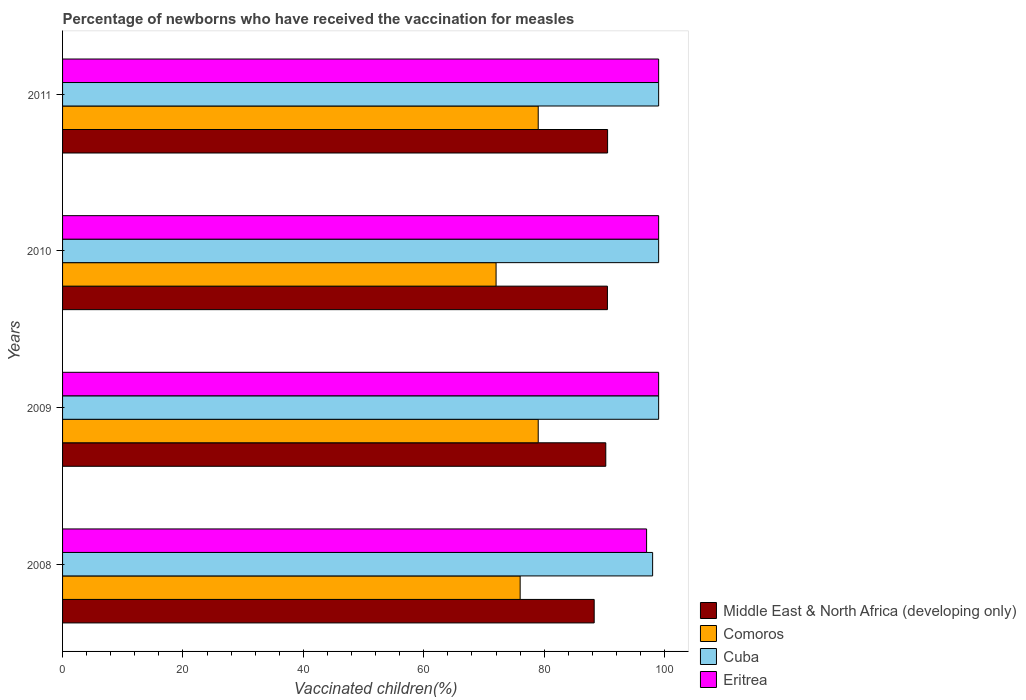How many different coloured bars are there?
Your answer should be very brief. 4. Are the number of bars per tick equal to the number of legend labels?
Provide a succinct answer. Yes. Are the number of bars on each tick of the Y-axis equal?
Make the answer very short. Yes. How many bars are there on the 2nd tick from the top?
Give a very brief answer. 4. In how many cases, is the number of bars for a given year not equal to the number of legend labels?
Provide a succinct answer. 0. What is the percentage of vaccinated children in Middle East & North Africa (developing only) in 2011?
Your answer should be very brief. 90.52. Across all years, what is the maximum percentage of vaccinated children in Middle East & North Africa (developing only)?
Make the answer very short. 90.52. Across all years, what is the minimum percentage of vaccinated children in Middle East & North Africa (developing only)?
Your answer should be very brief. 88.29. In which year was the percentage of vaccinated children in Middle East & North Africa (developing only) maximum?
Your answer should be very brief. 2011. What is the total percentage of vaccinated children in Middle East & North Africa (developing only) in the graph?
Keep it short and to the point. 359.53. What is the difference between the percentage of vaccinated children in Middle East & North Africa (developing only) in 2010 and that in 2011?
Keep it short and to the point. -0.03. What is the difference between the percentage of vaccinated children in Eritrea in 2010 and the percentage of vaccinated children in Middle East & North Africa (developing only) in 2009?
Offer a terse response. 8.78. What is the average percentage of vaccinated children in Cuba per year?
Your response must be concise. 98.75. In the year 2011, what is the difference between the percentage of vaccinated children in Eritrea and percentage of vaccinated children in Cuba?
Offer a very short reply. 0. Is the difference between the percentage of vaccinated children in Eritrea in 2009 and 2010 greater than the difference between the percentage of vaccinated children in Cuba in 2009 and 2010?
Provide a short and direct response. No. What is the difference between the highest and the lowest percentage of vaccinated children in Comoros?
Provide a succinct answer. 7. In how many years, is the percentage of vaccinated children in Comoros greater than the average percentage of vaccinated children in Comoros taken over all years?
Your response must be concise. 2. Is the sum of the percentage of vaccinated children in Comoros in 2008 and 2010 greater than the maximum percentage of vaccinated children in Middle East & North Africa (developing only) across all years?
Your answer should be very brief. Yes. Is it the case that in every year, the sum of the percentage of vaccinated children in Comoros and percentage of vaccinated children in Eritrea is greater than the sum of percentage of vaccinated children in Cuba and percentage of vaccinated children in Middle East & North Africa (developing only)?
Provide a succinct answer. No. What does the 3rd bar from the top in 2009 represents?
Your answer should be compact. Comoros. What does the 3rd bar from the bottom in 2011 represents?
Offer a terse response. Cuba. Is it the case that in every year, the sum of the percentage of vaccinated children in Comoros and percentage of vaccinated children in Cuba is greater than the percentage of vaccinated children in Eritrea?
Make the answer very short. Yes. How many bars are there?
Keep it short and to the point. 16. Are all the bars in the graph horizontal?
Your answer should be compact. Yes. Does the graph contain grids?
Ensure brevity in your answer.  No. How are the legend labels stacked?
Offer a terse response. Vertical. What is the title of the graph?
Give a very brief answer. Percentage of newborns who have received the vaccination for measles. Does "Guam" appear as one of the legend labels in the graph?
Your answer should be compact. No. What is the label or title of the X-axis?
Provide a short and direct response. Vaccinated children(%). What is the Vaccinated children(%) in Middle East & North Africa (developing only) in 2008?
Provide a short and direct response. 88.29. What is the Vaccinated children(%) of Comoros in 2008?
Give a very brief answer. 76. What is the Vaccinated children(%) of Cuba in 2008?
Give a very brief answer. 98. What is the Vaccinated children(%) of Eritrea in 2008?
Your answer should be very brief. 97. What is the Vaccinated children(%) of Middle East & North Africa (developing only) in 2009?
Your answer should be very brief. 90.22. What is the Vaccinated children(%) in Comoros in 2009?
Offer a terse response. 79. What is the Vaccinated children(%) in Cuba in 2009?
Provide a succinct answer. 99. What is the Vaccinated children(%) of Eritrea in 2009?
Your answer should be compact. 99. What is the Vaccinated children(%) in Middle East & North Africa (developing only) in 2010?
Offer a very short reply. 90.49. What is the Vaccinated children(%) in Comoros in 2010?
Your response must be concise. 72. What is the Vaccinated children(%) of Eritrea in 2010?
Make the answer very short. 99. What is the Vaccinated children(%) of Middle East & North Africa (developing only) in 2011?
Offer a terse response. 90.52. What is the Vaccinated children(%) in Comoros in 2011?
Your answer should be very brief. 79. What is the Vaccinated children(%) of Cuba in 2011?
Offer a very short reply. 99. Across all years, what is the maximum Vaccinated children(%) in Middle East & North Africa (developing only)?
Offer a very short reply. 90.52. Across all years, what is the maximum Vaccinated children(%) in Comoros?
Offer a terse response. 79. Across all years, what is the maximum Vaccinated children(%) in Cuba?
Keep it short and to the point. 99. Across all years, what is the minimum Vaccinated children(%) in Middle East & North Africa (developing only)?
Provide a succinct answer. 88.29. Across all years, what is the minimum Vaccinated children(%) in Eritrea?
Your answer should be very brief. 97. What is the total Vaccinated children(%) of Middle East & North Africa (developing only) in the graph?
Make the answer very short. 359.53. What is the total Vaccinated children(%) of Comoros in the graph?
Provide a short and direct response. 306. What is the total Vaccinated children(%) in Cuba in the graph?
Make the answer very short. 395. What is the total Vaccinated children(%) of Eritrea in the graph?
Provide a short and direct response. 394. What is the difference between the Vaccinated children(%) in Middle East & North Africa (developing only) in 2008 and that in 2009?
Your answer should be compact. -1.93. What is the difference between the Vaccinated children(%) of Comoros in 2008 and that in 2009?
Your answer should be very brief. -3. What is the difference between the Vaccinated children(%) in Cuba in 2008 and that in 2009?
Your answer should be very brief. -1. What is the difference between the Vaccinated children(%) of Eritrea in 2008 and that in 2009?
Offer a terse response. -2. What is the difference between the Vaccinated children(%) of Middle East & North Africa (developing only) in 2008 and that in 2010?
Provide a short and direct response. -2.2. What is the difference between the Vaccinated children(%) of Comoros in 2008 and that in 2010?
Provide a short and direct response. 4. What is the difference between the Vaccinated children(%) of Middle East & North Africa (developing only) in 2008 and that in 2011?
Offer a very short reply. -2.23. What is the difference between the Vaccinated children(%) of Middle East & North Africa (developing only) in 2009 and that in 2010?
Your answer should be very brief. -0.27. What is the difference between the Vaccinated children(%) of Eritrea in 2009 and that in 2010?
Your response must be concise. 0. What is the difference between the Vaccinated children(%) of Middle East & North Africa (developing only) in 2009 and that in 2011?
Make the answer very short. -0.3. What is the difference between the Vaccinated children(%) of Comoros in 2009 and that in 2011?
Provide a succinct answer. 0. What is the difference between the Vaccinated children(%) in Cuba in 2009 and that in 2011?
Keep it short and to the point. 0. What is the difference between the Vaccinated children(%) in Middle East & North Africa (developing only) in 2010 and that in 2011?
Offer a terse response. -0.03. What is the difference between the Vaccinated children(%) in Comoros in 2010 and that in 2011?
Ensure brevity in your answer.  -7. What is the difference between the Vaccinated children(%) in Cuba in 2010 and that in 2011?
Your response must be concise. 0. What is the difference between the Vaccinated children(%) in Middle East & North Africa (developing only) in 2008 and the Vaccinated children(%) in Comoros in 2009?
Ensure brevity in your answer.  9.29. What is the difference between the Vaccinated children(%) in Middle East & North Africa (developing only) in 2008 and the Vaccinated children(%) in Cuba in 2009?
Your answer should be very brief. -10.71. What is the difference between the Vaccinated children(%) of Middle East & North Africa (developing only) in 2008 and the Vaccinated children(%) of Eritrea in 2009?
Offer a terse response. -10.71. What is the difference between the Vaccinated children(%) in Cuba in 2008 and the Vaccinated children(%) in Eritrea in 2009?
Your response must be concise. -1. What is the difference between the Vaccinated children(%) of Middle East & North Africa (developing only) in 2008 and the Vaccinated children(%) of Comoros in 2010?
Your answer should be very brief. 16.29. What is the difference between the Vaccinated children(%) of Middle East & North Africa (developing only) in 2008 and the Vaccinated children(%) of Cuba in 2010?
Offer a terse response. -10.71. What is the difference between the Vaccinated children(%) in Middle East & North Africa (developing only) in 2008 and the Vaccinated children(%) in Eritrea in 2010?
Offer a terse response. -10.71. What is the difference between the Vaccinated children(%) in Comoros in 2008 and the Vaccinated children(%) in Cuba in 2010?
Give a very brief answer. -23. What is the difference between the Vaccinated children(%) of Middle East & North Africa (developing only) in 2008 and the Vaccinated children(%) of Comoros in 2011?
Ensure brevity in your answer.  9.29. What is the difference between the Vaccinated children(%) in Middle East & North Africa (developing only) in 2008 and the Vaccinated children(%) in Cuba in 2011?
Your answer should be very brief. -10.71. What is the difference between the Vaccinated children(%) in Middle East & North Africa (developing only) in 2008 and the Vaccinated children(%) in Eritrea in 2011?
Your response must be concise. -10.71. What is the difference between the Vaccinated children(%) in Cuba in 2008 and the Vaccinated children(%) in Eritrea in 2011?
Your answer should be very brief. -1. What is the difference between the Vaccinated children(%) in Middle East & North Africa (developing only) in 2009 and the Vaccinated children(%) in Comoros in 2010?
Your answer should be very brief. 18.22. What is the difference between the Vaccinated children(%) of Middle East & North Africa (developing only) in 2009 and the Vaccinated children(%) of Cuba in 2010?
Provide a succinct answer. -8.78. What is the difference between the Vaccinated children(%) of Middle East & North Africa (developing only) in 2009 and the Vaccinated children(%) of Eritrea in 2010?
Offer a very short reply. -8.78. What is the difference between the Vaccinated children(%) of Comoros in 2009 and the Vaccinated children(%) of Cuba in 2010?
Your answer should be compact. -20. What is the difference between the Vaccinated children(%) of Middle East & North Africa (developing only) in 2009 and the Vaccinated children(%) of Comoros in 2011?
Your response must be concise. 11.22. What is the difference between the Vaccinated children(%) in Middle East & North Africa (developing only) in 2009 and the Vaccinated children(%) in Cuba in 2011?
Offer a terse response. -8.78. What is the difference between the Vaccinated children(%) in Middle East & North Africa (developing only) in 2009 and the Vaccinated children(%) in Eritrea in 2011?
Offer a terse response. -8.78. What is the difference between the Vaccinated children(%) in Middle East & North Africa (developing only) in 2010 and the Vaccinated children(%) in Comoros in 2011?
Provide a short and direct response. 11.49. What is the difference between the Vaccinated children(%) in Middle East & North Africa (developing only) in 2010 and the Vaccinated children(%) in Cuba in 2011?
Give a very brief answer. -8.51. What is the difference between the Vaccinated children(%) of Middle East & North Africa (developing only) in 2010 and the Vaccinated children(%) of Eritrea in 2011?
Provide a short and direct response. -8.51. What is the difference between the Vaccinated children(%) in Comoros in 2010 and the Vaccinated children(%) in Eritrea in 2011?
Ensure brevity in your answer.  -27. What is the average Vaccinated children(%) of Middle East & North Africa (developing only) per year?
Your response must be concise. 89.88. What is the average Vaccinated children(%) of Comoros per year?
Give a very brief answer. 76.5. What is the average Vaccinated children(%) in Cuba per year?
Offer a very short reply. 98.75. What is the average Vaccinated children(%) of Eritrea per year?
Offer a terse response. 98.5. In the year 2008, what is the difference between the Vaccinated children(%) of Middle East & North Africa (developing only) and Vaccinated children(%) of Comoros?
Provide a succinct answer. 12.29. In the year 2008, what is the difference between the Vaccinated children(%) of Middle East & North Africa (developing only) and Vaccinated children(%) of Cuba?
Your answer should be very brief. -9.71. In the year 2008, what is the difference between the Vaccinated children(%) in Middle East & North Africa (developing only) and Vaccinated children(%) in Eritrea?
Offer a very short reply. -8.71. In the year 2008, what is the difference between the Vaccinated children(%) of Comoros and Vaccinated children(%) of Eritrea?
Ensure brevity in your answer.  -21. In the year 2008, what is the difference between the Vaccinated children(%) of Cuba and Vaccinated children(%) of Eritrea?
Ensure brevity in your answer.  1. In the year 2009, what is the difference between the Vaccinated children(%) in Middle East & North Africa (developing only) and Vaccinated children(%) in Comoros?
Offer a very short reply. 11.22. In the year 2009, what is the difference between the Vaccinated children(%) in Middle East & North Africa (developing only) and Vaccinated children(%) in Cuba?
Your response must be concise. -8.78. In the year 2009, what is the difference between the Vaccinated children(%) in Middle East & North Africa (developing only) and Vaccinated children(%) in Eritrea?
Provide a short and direct response. -8.78. In the year 2009, what is the difference between the Vaccinated children(%) in Comoros and Vaccinated children(%) in Cuba?
Your answer should be compact. -20. In the year 2009, what is the difference between the Vaccinated children(%) of Comoros and Vaccinated children(%) of Eritrea?
Your answer should be very brief. -20. In the year 2009, what is the difference between the Vaccinated children(%) of Cuba and Vaccinated children(%) of Eritrea?
Ensure brevity in your answer.  0. In the year 2010, what is the difference between the Vaccinated children(%) in Middle East & North Africa (developing only) and Vaccinated children(%) in Comoros?
Make the answer very short. 18.49. In the year 2010, what is the difference between the Vaccinated children(%) in Middle East & North Africa (developing only) and Vaccinated children(%) in Cuba?
Your response must be concise. -8.51. In the year 2010, what is the difference between the Vaccinated children(%) in Middle East & North Africa (developing only) and Vaccinated children(%) in Eritrea?
Your answer should be very brief. -8.51. In the year 2010, what is the difference between the Vaccinated children(%) in Comoros and Vaccinated children(%) in Cuba?
Keep it short and to the point. -27. In the year 2010, what is the difference between the Vaccinated children(%) in Cuba and Vaccinated children(%) in Eritrea?
Your answer should be compact. 0. In the year 2011, what is the difference between the Vaccinated children(%) in Middle East & North Africa (developing only) and Vaccinated children(%) in Comoros?
Your response must be concise. 11.52. In the year 2011, what is the difference between the Vaccinated children(%) of Middle East & North Africa (developing only) and Vaccinated children(%) of Cuba?
Offer a terse response. -8.48. In the year 2011, what is the difference between the Vaccinated children(%) in Middle East & North Africa (developing only) and Vaccinated children(%) in Eritrea?
Provide a succinct answer. -8.48. In the year 2011, what is the difference between the Vaccinated children(%) of Comoros and Vaccinated children(%) of Cuba?
Keep it short and to the point. -20. In the year 2011, what is the difference between the Vaccinated children(%) in Comoros and Vaccinated children(%) in Eritrea?
Make the answer very short. -20. In the year 2011, what is the difference between the Vaccinated children(%) in Cuba and Vaccinated children(%) in Eritrea?
Offer a terse response. 0. What is the ratio of the Vaccinated children(%) of Middle East & North Africa (developing only) in 2008 to that in 2009?
Ensure brevity in your answer.  0.98. What is the ratio of the Vaccinated children(%) of Cuba in 2008 to that in 2009?
Keep it short and to the point. 0.99. What is the ratio of the Vaccinated children(%) in Eritrea in 2008 to that in 2009?
Your answer should be compact. 0.98. What is the ratio of the Vaccinated children(%) in Middle East & North Africa (developing only) in 2008 to that in 2010?
Your response must be concise. 0.98. What is the ratio of the Vaccinated children(%) of Comoros in 2008 to that in 2010?
Offer a very short reply. 1.06. What is the ratio of the Vaccinated children(%) in Cuba in 2008 to that in 2010?
Offer a very short reply. 0.99. What is the ratio of the Vaccinated children(%) of Eritrea in 2008 to that in 2010?
Give a very brief answer. 0.98. What is the ratio of the Vaccinated children(%) in Middle East & North Africa (developing only) in 2008 to that in 2011?
Your answer should be very brief. 0.98. What is the ratio of the Vaccinated children(%) of Comoros in 2008 to that in 2011?
Your answer should be compact. 0.96. What is the ratio of the Vaccinated children(%) in Eritrea in 2008 to that in 2011?
Your answer should be compact. 0.98. What is the ratio of the Vaccinated children(%) in Comoros in 2009 to that in 2010?
Provide a short and direct response. 1.1. What is the ratio of the Vaccinated children(%) in Cuba in 2009 to that in 2010?
Provide a short and direct response. 1. What is the ratio of the Vaccinated children(%) of Comoros in 2009 to that in 2011?
Give a very brief answer. 1. What is the ratio of the Vaccinated children(%) in Cuba in 2009 to that in 2011?
Make the answer very short. 1. What is the ratio of the Vaccinated children(%) in Middle East & North Africa (developing only) in 2010 to that in 2011?
Your answer should be very brief. 1. What is the ratio of the Vaccinated children(%) of Comoros in 2010 to that in 2011?
Your response must be concise. 0.91. What is the ratio of the Vaccinated children(%) of Eritrea in 2010 to that in 2011?
Your answer should be very brief. 1. What is the difference between the highest and the second highest Vaccinated children(%) in Middle East & North Africa (developing only)?
Ensure brevity in your answer.  0.03. What is the difference between the highest and the lowest Vaccinated children(%) of Middle East & North Africa (developing only)?
Keep it short and to the point. 2.23. What is the difference between the highest and the lowest Vaccinated children(%) in Cuba?
Give a very brief answer. 1. What is the difference between the highest and the lowest Vaccinated children(%) of Eritrea?
Make the answer very short. 2. 